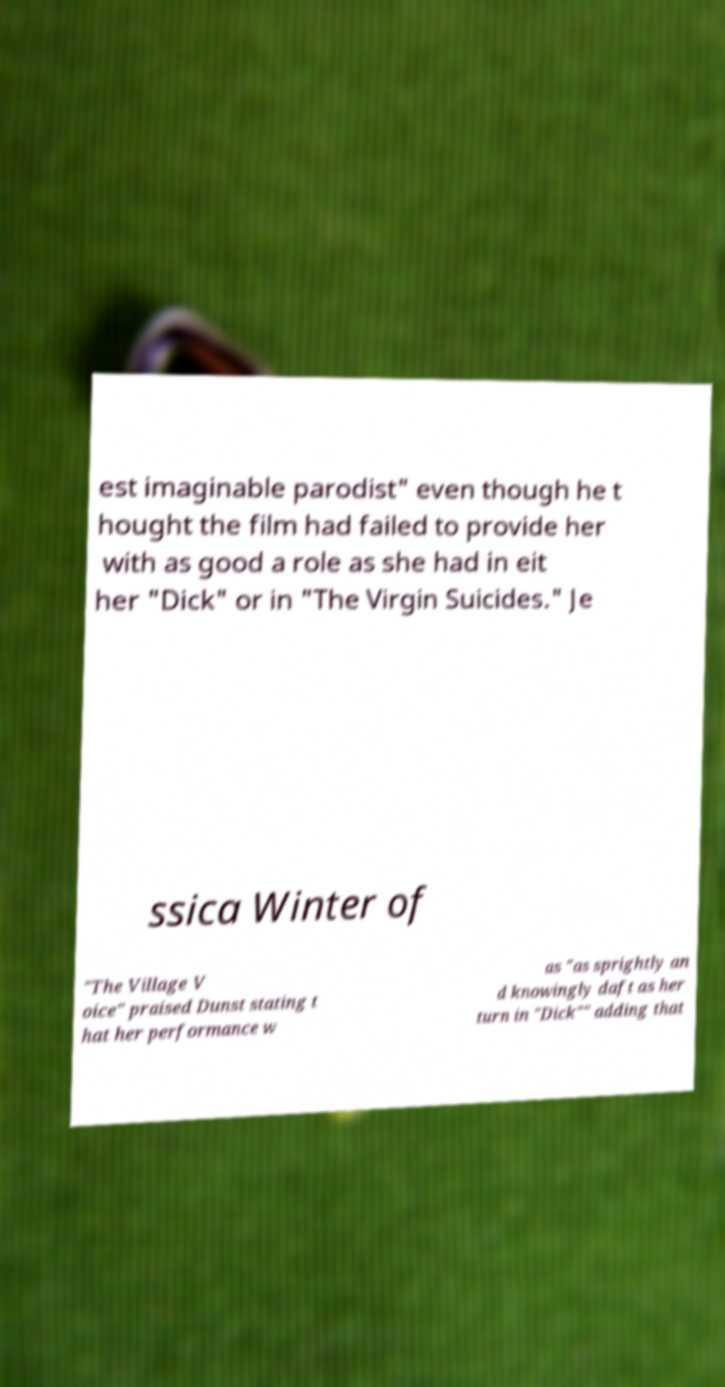I need the written content from this picture converted into text. Can you do that? est imaginable parodist" even though he t hought the film had failed to provide her with as good a role as she had in eit her "Dick" or in "The Virgin Suicides." Je ssica Winter of "The Village V oice" praised Dunst stating t hat her performance w as "as sprightly an d knowingly daft as her turn in "Dick"" adding that 